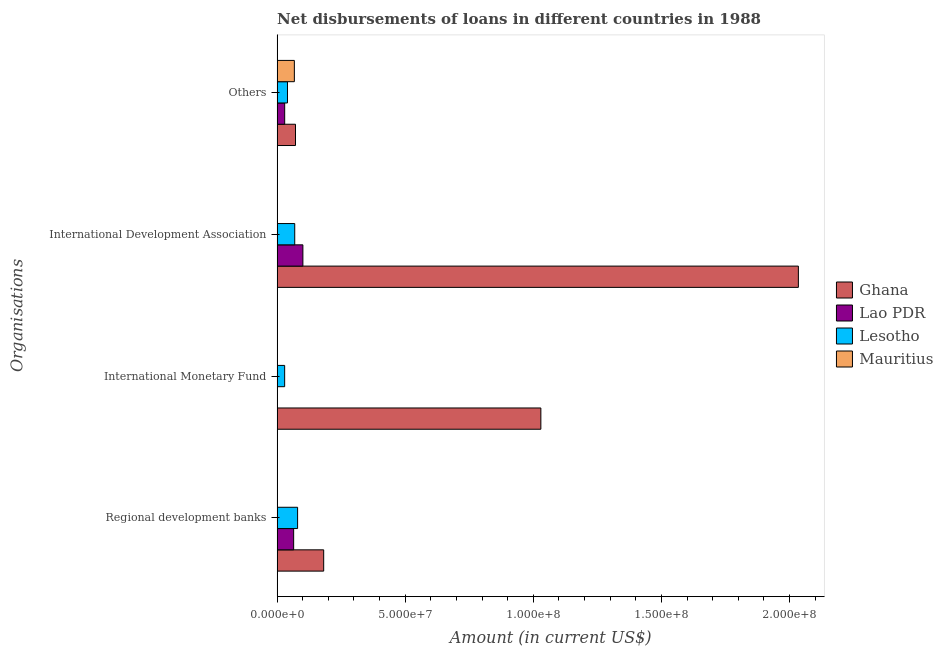How many groups of bars are there?
Offer a very short reply. 4. Are the number of bars per tick equal to the number of legend labels?
Give a very brief answer. No. How many bars are there on the 3rd tick from the top?
Your answer should be very brief. 2. What is the label of the 1st group of bars from the top?
Offer a terse response. Others. What is the amount of loan disimbursed by regional development banks in Lesotho?
Ensure brevity in your answer.  7.99e+06. Across all countries, what is the maximum amount of loan disimbursed by regional development banks?
Provide a short and direct response. 1.82e+07. What is the total amount of loan disimbursed by international monetary fund in the graph?
Your answer should be compact. 1.06e+08. What is the difference between the amount of loan disimbursed by regional development banks in Ghana and that in Lesotho?
Offer a terse response. 1.02e+07. What is the difference between the amount of loan disimbursed by international development association in Ghana and the amount of loan disimbursed by other organisations in Lao PDR?
Your answer should be very brief. 2.01e+08. What is the average amount of loan disimbursed by international development association per country?
Keep it short and to the point. 5.51e+07. What is the difference between the amount of loan disimbursed by regional development banks and amount of loan disimbursed by international development association in Lesotho?
Offer a terse response. 1.12e+06. In how many countries, is the amount of loan disimbursed by regional development banks greater than 10000000 US$?
Your response must be concise. 1. What is the ratio of the amount of loan disimbursed by other organisations in Lesotho to that in Lao PDR?
Your answer should be compact. 1.37. What is the difference between the highest and the second highest amount of loan disimbursed by international development association?
Make the answer very short. 1.93e+08. What is the difference between the highest and the lowest amount of loan disimbursed by international monetary fund?
Provide a succinct answer. 1.03e+08. In how many countries, is the amount of loan disimbursed by regional development banks greater than the average amount of loan disimbursed by regional development banks taken over all countries?
Your response must be concise. 1. Is it the case that in every country, the sum of the amount of loan disimbursed by regional development banks and amount of loan disimbursed by international monetary fund is greater than the amount of loan disimbursed by international development association?
Keep it short and to the point. No. Are all the bars in the graph horizontal?
Your answer should be compact. Yes. Does the graph contain any zero values?
Provide a succinct answer. Yes. What is the title of the graph?
Offer a terse response. Net disbursements of loans in different countries in 1988. Does "Fiji" appear as one of the legend labels in the graph?
Ensure brevity in your answer.  No. What is the label or title of the Y-axis?
Your answer should be very brief. Organisations. What is the Amount (in current US$) of Ghana in Regional development banks?
Your answer should be very brief. 1.82e+07. What is the Amount (in current US$) of Lao PDR in Regional development banks?
Your answer should be very brief. 6.45e+06. What is the Amount (in current US$) of Lesotho in Regional development banks?
Offer a very short reply. 7.99e+06. What is the Amount (in current US$) of Ghana in International Monetary Fund?
Offer a terse response. 1.03e+08. What is the Amount (in current US$) in Lao PDR in International Monetary Fund?
Your answer should be very brief. 0. What is the Amount (in current US$) of Lesotho in International Monetary Fund?
Provide a short and direct response. 2.94e+06. What is the Amount (in current US$) in Ghana in International Development Association?
Give a very brief answer. 2.03e+08. What is the Amount (in current US$) of Lao PDR in International Development Association?
Ensure brevity in your answer.  1.01e+07. What is the Amount (in current US$) in Lesotho in International Development Association?
Your answer should be very brief. 6.87e+06. What is the Amount (in current US$) of Ghana in Others?
Your response must be concise. 7.17e+06. What is the Amount (in current US$) in Lao PDR in Others?
Keep it short and to the point. 2.95e+06. What is the Amount (in current US$) of Lesotho in Others?
Provide a succinct answer. 4.05e+06. What is the Amount (in current US$) of Mauritius in Others?
Keep it short and to the point. 6.73e+06. Across all Organisations, what is the maximum Amount (in current US$) in Ghana?
Offer a very short reply. 2.03e+08. Across all Organisations, what is the maximum Amount (in current US$) in Lao PDR?
Your answer should be compact. 1.01e+07. Across all Organisations, what is the maximum Amount (in current US$) in Lesotho?
Ensure brevity in your answer.  7.99e+06. Across all Organisations, what is the maximum Amount (in current US$) in Mauritius?
Provide a short and direct response. 6.73e+06. Across all Organisations, what is the minimum Amount (in current US$) of Ghana?
Your answer should be very brief. 7.17e+06. Across all Organisations, what is the minimum Amount (in current US$) of Lao PDR?
Offer a terse response. 0. Across all Organisations, what is the minimum Amount (in current US$) in Lesotho?
Give a very brief answer. 2.94e+06. Across all Organisations, what is the minimum Amount (in current US$) in Mauritius?
Offer a terse response. 0. What is the total Amount (in current US$) in Ghana in the graph?
Give a very brief answer. 3.32e+08. What is the total Amount (in current US$) in Lao PDR in the graph?
Offer a very short reply. 1.95e+07. What is the total Amount (in current US$) in Lesotho in the graph?
Provide a succinct answer. 2.18e+07. What is the total Amount (in current US$) of Mauritius in the graph?
Keep it short and to the point. 6.73e+06. What is the difference between the Amount (in current US$) in Ghana in Regional development banks and that in International Monetary Fund?
Offer a terse response. -8.48e+07. What is the difference between the Amount (in current US$) of Lesotho in Regional development banks and that in International Monetary Fund?
Your response must be concise. 5.05e+06. What is the difference between the Amount (in current US$) in Ghana in Regional development banks and that in International Development Association?
Give a very brief answer. -1.85e+08. What is the difference between the Amount (in current US$) in Lao PDR in Regional development banks and that in International Development Association?
Give a very brief answer. -3.61e+06. What is the difference between the Amount (in current US$) in Lesotho in Regional development banks and that in International Development Association?
Ensure brevity in your answer.  1.12e+06. What is the difference between the Amount (in current US$) of Ghana in Regional development banks and that in Others?
Give a very brief answer. 1.10e+07. What is the difference between the Amount (in current US$) in Lao PDR in Regional development banks and that in Others?
Give a very brief answer. 3.50e+06. What is the difference between the Amount (in current US$) in Lesotho in Regional development banks and that in Others?
Your answer should be very brief. 3.94e+06. What is the difference between the Amount (in current US$) in Ghana in International Monetary Fund and that in International Development Association?
Provide a succinct answer. -1.01e+08. What is the difference between the Amount (in current US$) in Lesotho in International Monetary Fund and that in International Development Association?
Your response must be concise. -3.93e+06. What is the difference between the Amount (in current US$) in Ghana in International Monetary Fund and that in Others?
Provide a succinct answer. 9.58e+07. What is the difference between the Amount (in current US$) in Lesotho in International Monetary Fund and that in Others?
Your answer should be compact. -1.11e+06. What is the difference between the Amount (in current US$) in Ghana in International Development Association and that in Others?
Offer a terse response. 1.96e+08. What is the difference between the Amount (in current US$) in Lao PDR in International Development Association and that in Others?
Your answer should be compact. 7.11e+06. What is the difference between the Amount (in current US$) of Lesotho in International Development Association and that in Others?
Provide a succinct answer. 2.83e+06. What is the difference between the Amount (in current US$) in Ghana in Regional development banks and the Amount (in current US$) in Lesotho in International Monetary Fund?
Ensure brevity in your answer.  1.52e+07. What is the difference between the Amount (in current US$) of Lao PDR in Regional development banks and the Amount (in current US$) of Lesotho in International Monetary Fund?
Your response must be concise. 3.51e+06. What is the difference between the Amount (in current US$) of Ghana in Regional development banks and the Amount (in current US$) of Lao PDR in International Development Association?
Offer a terse response. 8.12e+06. What is the difference between the Amount (in current US$) of Ghana in Regional development banks and the Amount (in current US$) of Lesotho in International Development Association?
Give a very brief answer. 1.13e+07. What is the difference between the Amount (in current US$) of Lao PDR in Regional development banks and the Amount (in current US$) of Lesotho in International Development Association?
Your answer should be very brief. -4.21e+05. What is the difference between the Amount (in current US$) of Ghana in Regional development banks and the Amount (in current US$) of Lao PDR in Others?
Offer a very short reply. 1.52e+07. What is the difference between the Amount (in current US$) of Ghana in Regional development banks and the Amount (in current US$) of Lesotho in Others?
Provide a short and direct response. 1.41e+07. What is the difference between the Amount (in current US$) of Ghana in Regional development banks and the Amount (in current US$) of Mauritius in Others?
Make the answer very short. 1.14e+07. What is the difference between the Amount (in current US$) of Lao PDR in Regional development banks and the Amount (in current US$) of Lesotho in Others?
Ensure brevity in your answer.  2.41e+06. What is the difference between the Amount (in current US$) of Lao PDR in Regional development banks and the Amount (in current US$) of Mauritius in Others?
Provide a short and direct response. -2.73e+05. What is the difference between the Amount (in current US$) in Lesotho in Regional development banks and the Amount (in current US$) in Mauritius in Others?
Offer a terse response. 1.26e+06. What is the difference between the Amount (in current US$) in Ghana in International Monetary Fund and the Amount (in current US$) in Lao PDR in International Development Association?
Ensure brevity in your answer.  9.29e+07. What is the difference between the Amount (in current US$) in Ghana in International Monetary Fund and the Amount (in current US$) in Lesotho in International Development Association?
Your answer should be compact. 9.61e+07. What is the difference between the Amount (in current US$) in Ghana in International Monetary Fund and the Amount (in current US$) in Lao PDR in Others?
Your answer should be compact. 1.00e+08. What is the difference between the Amount (in current US$) in Ghana in International Monetary Fund and the Amount (in current US$) in Lesotho in Others?
Offer a terse response. 9.89e+07. What is the difference between the Amount (in current US$) in Ghana in International Monetary Fund and the Amount (in current US$) in Mauritius in Others?
Your answer should be compact. 9.62e+07. What is the difference between the Amount (in current US$) of Lesotho in International Monetary Fund and the Amount (in current US$) of Mauritius in Others?
Make the answer very short. -3.79e+06. What is the difference between the Amount (in current US$) in Ghana in International Development Association and the Amount (in current US$) in Lao PDR in Others?
Provide a succinct answer. 2.01e+08. What is the difference between the Amount (in current US$) of Ghana in International Development Association and the Amount (in current US$) of Lesotho in Others?
Provide a succinct answer. 1.99e+08. What is the difference between the Amount (in current US$) in Ghana in International Development Association and the Amount (in current US$) in Mauritius in Others?
Your answer should be very brief. 1.97e+08. What is the difference between the Amount (in current US$) of Lao PDR in International Development Association and the Amount (in current US$) of Lesotho in Others?
Your response must be concise. 6.01e+06. What is the difference between the Amount (in current US$) in Lao PDR in International Development Association and the Amount (in current US$) in Mauritius in Others?
Give a very brief answer. 3.33e+06. What is the difference between the Amount (in current US$) of Lesotho in International Development Association and the Amount (in current US$) of Mauritius in Others?
Your answer should be compact. 1.48e+05. What is the average Amount (in current US$) of Ghana per Organisations?
Your answer should be compact. 8.29e+07. What is the average Amount (in current US$) of Lao PDR per Organisations?
Provide a succinct answer. 4.87e+06. What is the average Amount (in current US$) of Lesotho per Organisations?
Your response must be concise. 5.46e+06. What is the average Amount (in current US$) of Mauritius per Organisations?
Provide a short and direct response. 1.68e+06. What is the difference between the Amount (in current US$) of Ghana and Amount (in current US$) of Lao PDR in Regional development banks?
Your answer should be very brief. 1.17e+07. What is the difference between the Amount (in current US$) of Ghana and Amount (in current US$) of Lesotho in Regional development banks?
Offer a very short reply. 1.02e+07. What is the difference between the Amount (in current US$) of Lao PDR and Amount (in current US$) of Lesotho in Regional development banks?
Ensure brevity in your answer.  -1.54e+06. What is the difference between the Amount (in current US$) of Ghana and Amount (in current US$) of Lao PDR in International Development Association?
Ensure brevity in your answer.  1.93e+08. What is the difference between the Amount (in current US$) of Ghana and Amount (in current US$) of Lesotho in International Development Association?
Give a very brief answer. 1.97e+08. What is the difference between the Amount (in current US$) of Lao PDR and Amount (in current US$) of Lesotho in International Development Association?
Offer a terse response. 3.18e+06. What is the difference between the Amount (in current US$) in Ghana and Amount (in current US$) in Lao PDR in Others?
Your response must be concise. 4.22e+06. What is the difference between the Amount (in current US$) of Ghana and Amount (in current US$) of Lesotho in Others?
Give a very brief answer. 3.13e+06. What is the difference between the Amount (in current US$) in Ghana and Amount (in current US$) in Mauritius in Others?
Provide a succinct answer. 4.47e+05. What is the difference between the Amount (in current US$) of Lao PDR and Amount (in current US$) of Lesotho in Others?
Offer a terse response. -1.10e+06. What is the difference between the Amount (in current US$) of Lao PDR and Amount (in current US$) of Mauritius in Others?
Provide a succinct answer. -3.78e+06. What is the difference between the Amount (in current US$) in Lesotho and Amount (in current US$) in Mauritius in Others?
Make the answer very short. -2.68e+06. What is the ratio of the Amount (in current US$) of Ghana in Regional development banks to that in International Monetary Fund?
Give a very brief answer. 0.18. What is the ratio of the Amount (in current US$) in Lesotho in Regional development banks to that in International Monetary Fund?
Provide a short and direct response. 2.72. What is the ratio of the Amount (in current US$) of Ghana in Regional development banks to that in International Development Association?
Provide a succinct answer. 0.09. What is the ratio of the Amount (in current US$) in Lao PDR in Regional development banks to that in International Development Association?
Offer a very short reply. 0.64. What is the ratio of the Amount (in current US$) in Lesotho in Regional development banks to that in International Development Association?
Ensure brevity in your answer.  1.16. What is the ratio of the Amount (in current US$) in Ghana in Regional development banks to that in Others?
Offer a very short reply. 2.53. What is the ratio of the Amount (in current US$) of Lao PDR in Regional development banks to that in Others?
Give a very brief answer. 2.19. What is the ratio of the Amount (in current US$) of Lesotho in Regional development banks to that in Others?
Offer a terse response. 1.97. What is the ratio of the Amount (in current US$) in Ghana in International Monetary Fund to that in International Development Association?
Give a very brief answer. 0.51. What is the ratio of the Amount (in current US$) in Lesotho in International Monetary Fund to that in International Development Association?
Offer a terse response. 0.43. What is the ratio of the Amount (in current US$) of Ghana in International Monetary Fund to that in Others?
Offer a very short reply. 14.35. What is the ratio of the Amount (in current US$) of Lesotho in International Monetary Fund to that in Others?
Give a very brief answer. 0.73. What is the ratio of the Amount (in current US$) in Ghana in International Development Association to that in Others?
Your answer should be very brief. 28.36. What is the ratio of the Amount (in current US$) in Lao PDR in International Development Association to that in Others?
Make the answer very short. 3.41. What is the ratio of the Amount (in current US$) in Lesotho in International Development Association to that in Others?
Ensure brevity in your answer.  1.7. What is the difference between the highest and the second highest Amount (in current US$) in Ghana?
Provide a succinct answer. 1.01e+08. What is the difference between the highest and the second highest Amount (in current US$) of Lao PDR?
Make the answer very short. 3.61e+06. What is the difference between the highest and the second highest Amount (in current US$) of Lesotho?
Provide a succinct answer. 1.12e+06. What is the difference between the highest and the lowest Amount (in current US$) of Ghana?
Give a very brief answer. 1.96e+08. What is the difference between the highest and the lowest Amount (in current US$) in Lao PDR?
Your answer should be compact. 1.01e+07. What is the difference between the highest and the lowest Amount (in current US$) in Lesotho?
Give a very brief answer. 5.05e+06. What is the difference between the highest and the lowest Amount (in current US$) of Mauritius?
Keep it short and to the point. 6.73e+06. 